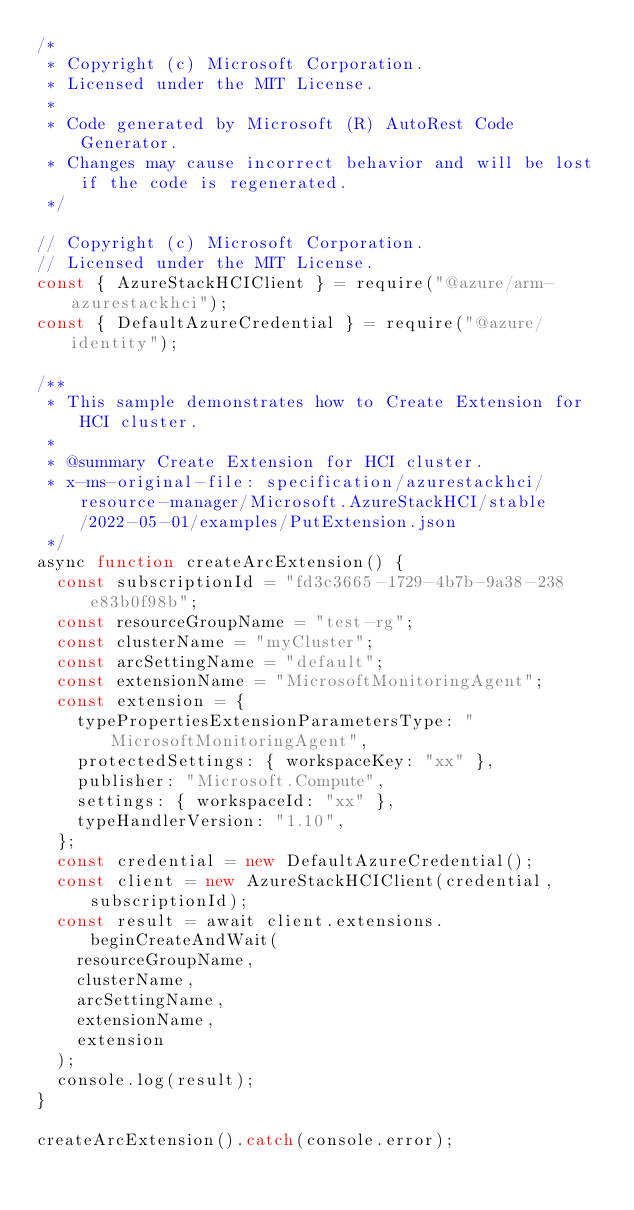<code> <loc_0><loc_0><loc_500><loc_500><_JavaScript_>/*
 * Copyright (c) Microsoft Corporation.
 * Licensed under the MIT License.
 *
 * Code generated by Microsoft (R) AutoRest Code Generator.
 * Changes may cause incorrect behavior and will be lost if the code is regenerated.
 */

// Copyright (c) Microsoft Corporation.
// Licensed under the MIT License.
const { AzureStackHCIClient } = require("@azure/arm-azurestackhci");
const { DefaultAzureCredential } = require("@azure/identity");

/**
 * This sample demonstrates how to Create Extension for HCI cluster.
 *
 * @summary Create Extension for HCI cluster.
 * x-ms-original-file: specification/azurestackhci/resource-manager/Microsoft.AzureStackHCI/stable/2022-05-01/examples/PutExtension.json
 */
async function createArcExtension() {
  const subscriptionId = "fd3c3665-1729-4b7b-9a38-238e83b0f98b";
  const resourceGroupName = "test-rg";
  const clusterName = "myCluster";
  const arcSettingName = "default";
  const extensionName = "MicrosoftMonitoringAgent";
  const extension = {
    typePropertiesExtensionParametersType: "MicrosoftMonitoringAgent",
    protectedSettings: { workspaceKey: "xx" },
    publisher: "Microsoft.Compute",
    settings: { workspaceId: "xx" },
    typeHandlerVersion: "1.10",
  };
  const credential = new DefaultAzureCredential();
  const client = new AzureStackHCIClient(credential, subscriptionId);
  const result = await client.extensions.beginCreateAndWait(
    resourceGroupName,
    clusterName,
    arcSettingName,
    extensionName,
    extension
  );
  console.log(result);
}

createArcExtension().catch(console.error);
</code> 